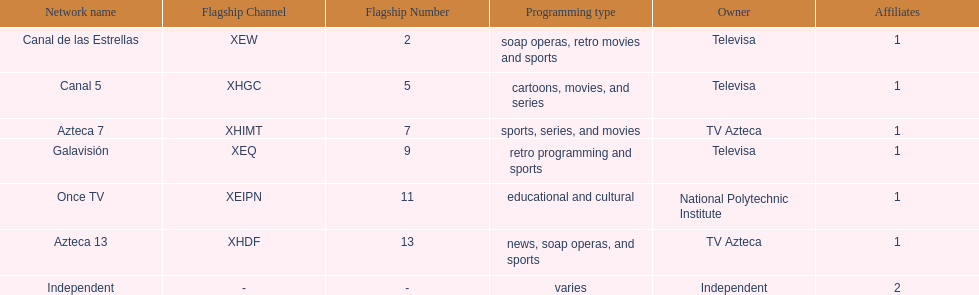Azteca 7 and azteca 13 are both owned by whom? TV Azteca. 